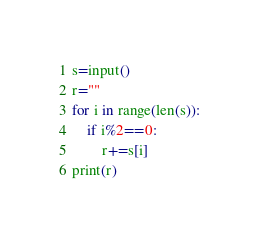<code> <loc_0><loc_0><loc_500><loc_500><_Python_>s=input()
r=""
for i in range(len(s)):
    if i%2==0:
        r+=s[i]
print(r)</code> 